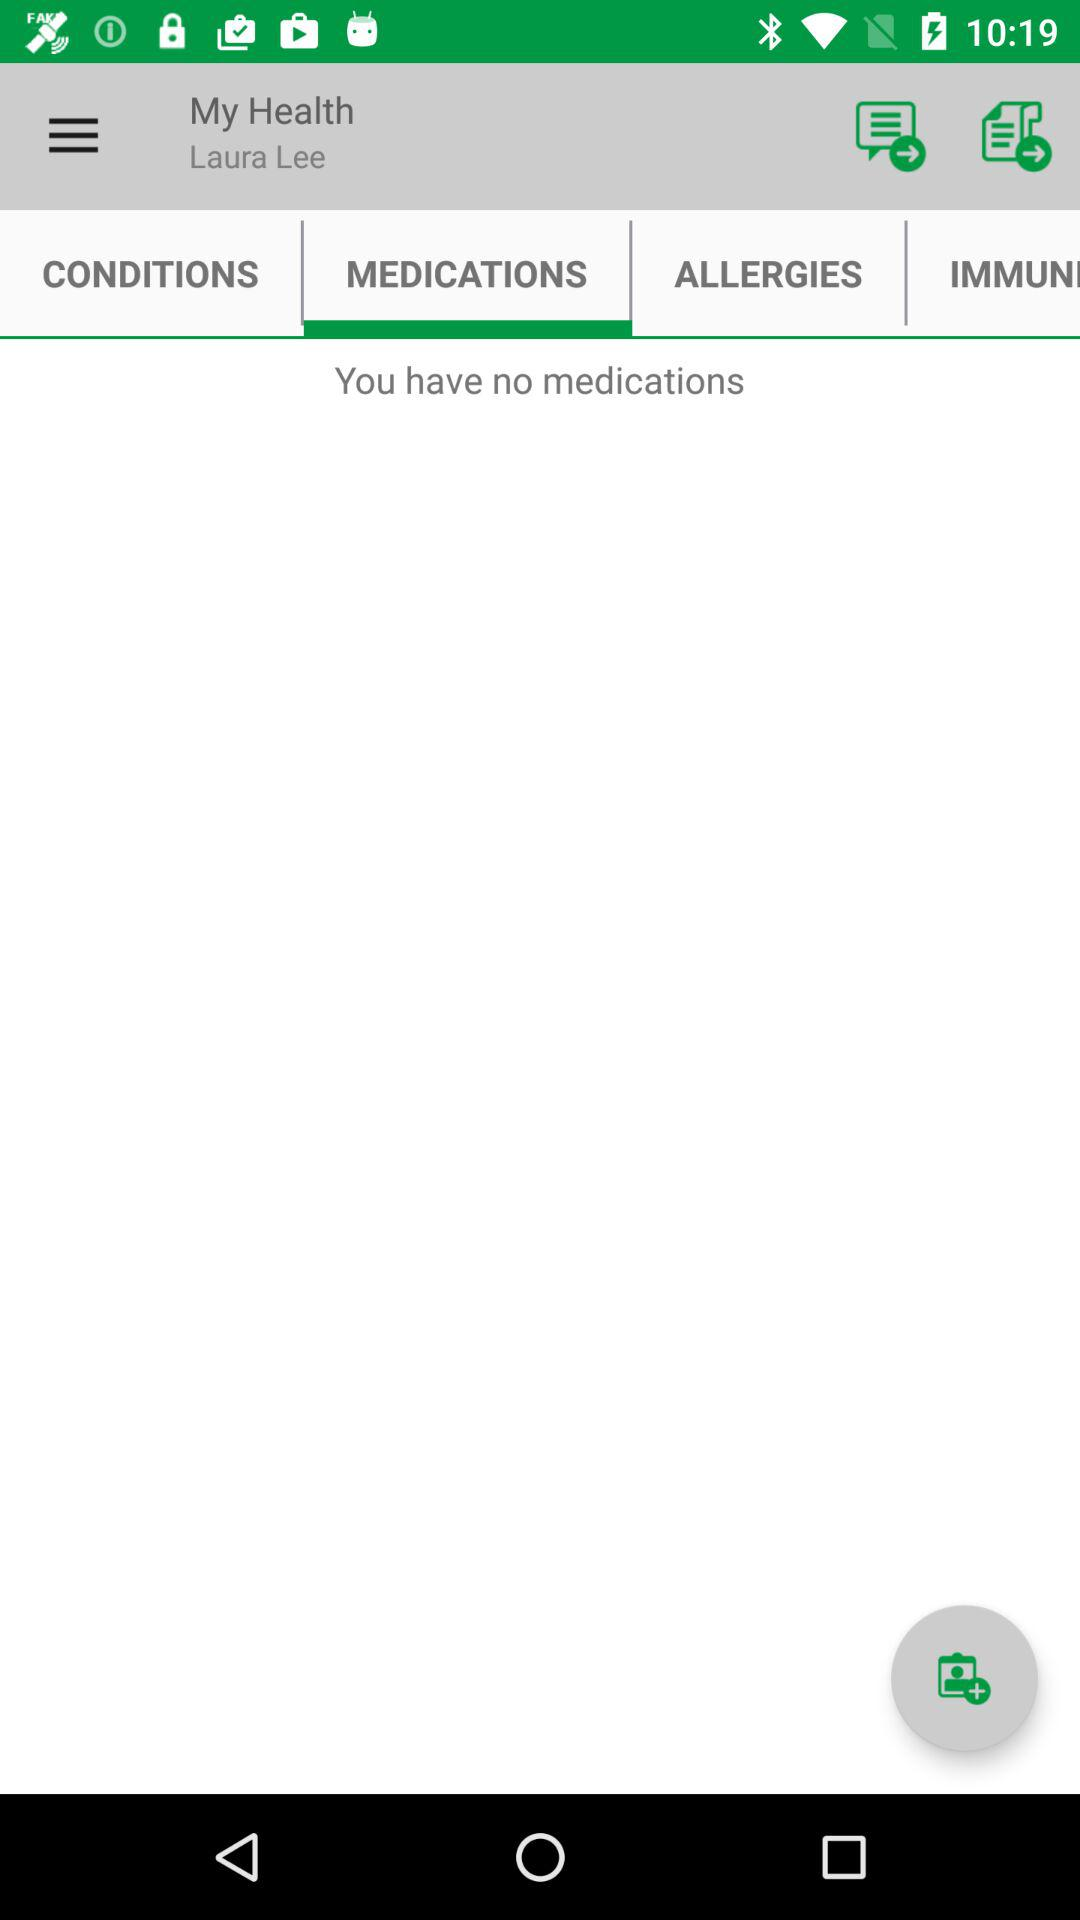Which tab are we on? We are on the tab "MEDICATIONS". 